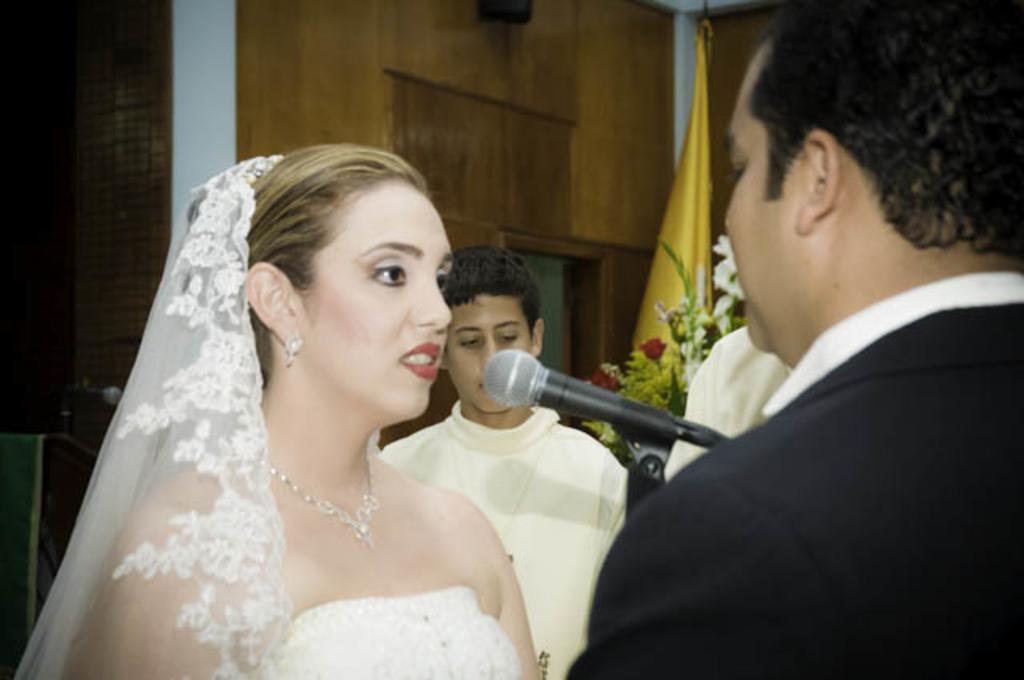Could you give a brief overview of what you see in this image? In this picture there is a woman standing and she might be talking and there are three people standing. At the back there is a flag and there are flowers and microphones and there is a podium. There is an object on the wall. 